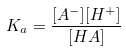<formula> <loc_0><loc_0><loc_500><loc_500>K _ { a } = \frac { [ A ^ { - } ] [ H ^ { + } ] } { [ H A ] }</formula> 